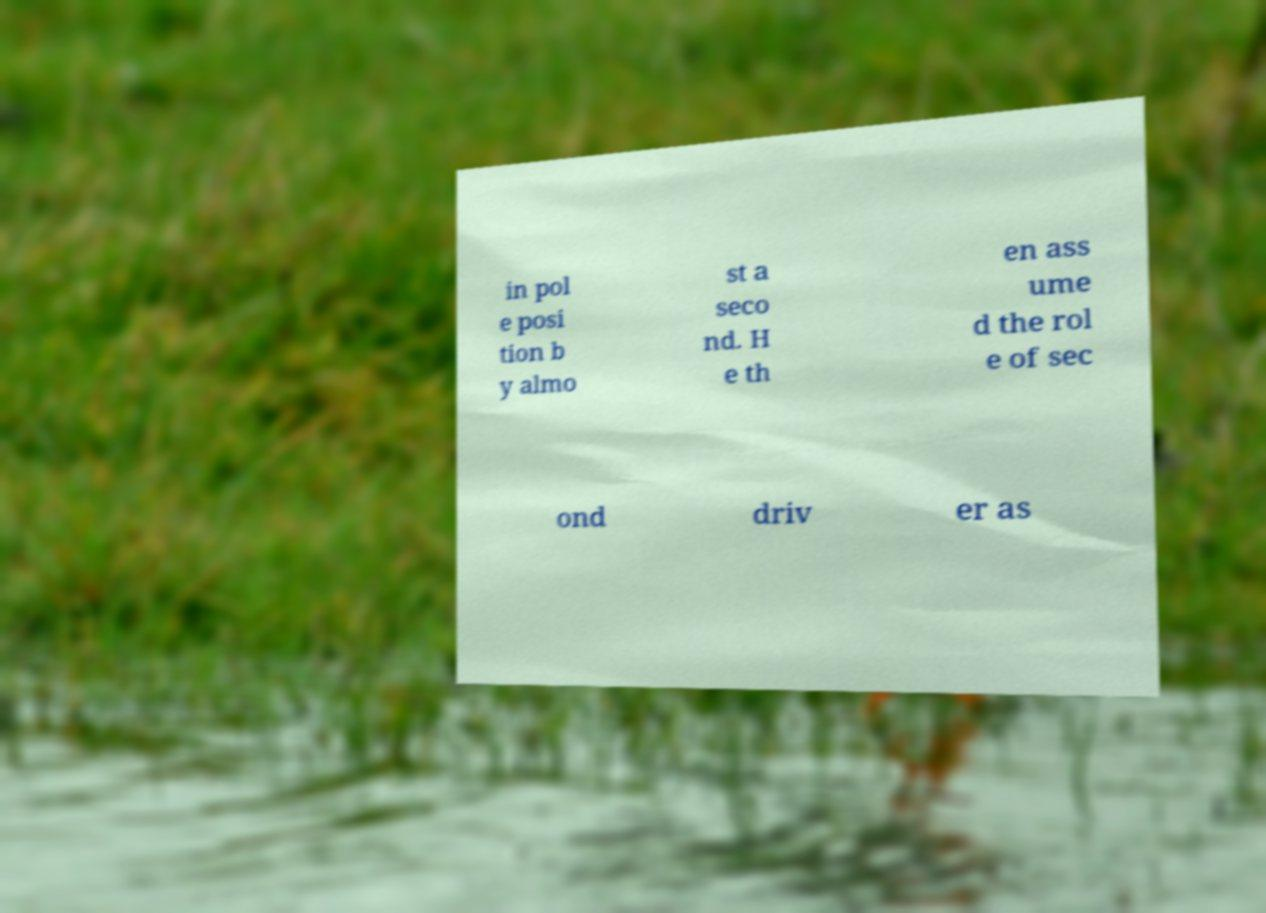Can you read and provide the text displayed in the image?This photo seems to have some interesting text. Can you extract and type it out for me? in pol e posi tion b y almo st a seco nd. H e th en ass ume d the rol e of sec ond driv er as 